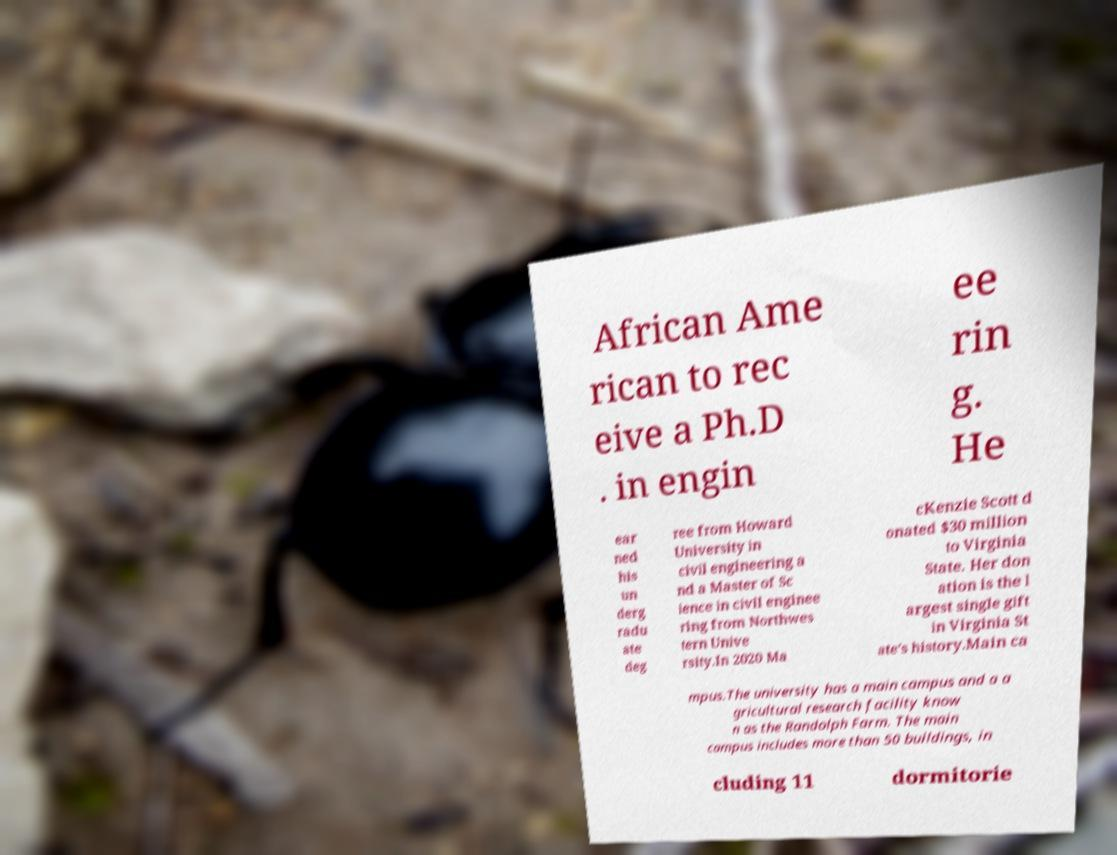Could you extract and type out the text from this image? African Ame rican to rec eive a Ph.D . in engin ee rin g. He ear ned his un derg radu ate deg ree from Howard University in civil engineering a nd a Master of Sc ience in civil enginee ring from Northwes tern Unive rsity.In 2020 Ma cKenzie Scott d onated $30 million to Virginia State. Her don ation is the l argest single gift in Virginia St ate's history.Main ca mpus.The university has a main campus and a a gricultural research facility know n as the Randolph Farm. The main campus includes more than 50 buildings, in cluding 11 dormitorie 